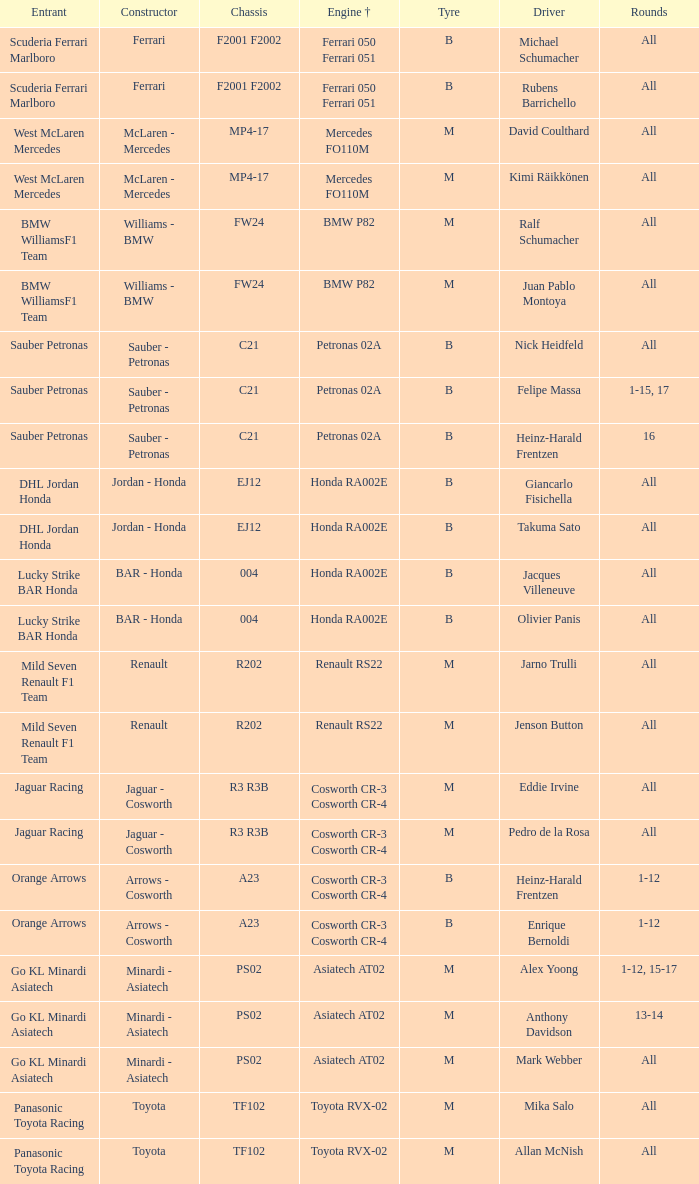What is the engine when the rounds ar all, the tyre is m and the driver is david coulthard? Mercedes FO110M. 